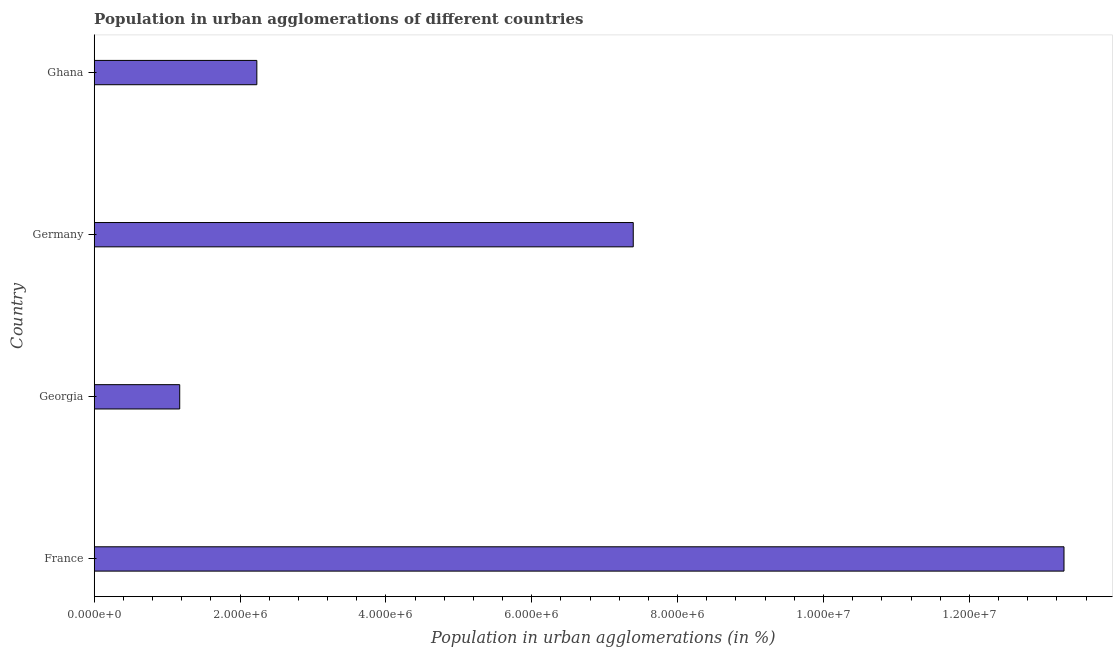Does the graph contain any zero values?
Your answer should be compact. No. What is the title of the graph?
Keep it short and to the point. Population in urban agglomerations of different countries. What is the label or title of the X-axis?
Your answer should be very brief. Population in urban agglomerations (in %). What is the population in urban agglomerations in Germany?
Keep it short and to the point. 7.39e+06. Across all countries, what is the maximum population in urban agglomerations?
Give a very brief answer. 1.33e+07. Across all countries, what is the minimum population in urban agglomerations?
Ensure brevity in your answer.  1.17e+06. In which country was the population in urban agglomerations maximum?
Your response must be concise. France. In which country was the population in urban agglomerations minimum?
Provide a short and direct response. Georgia. What is the sum of the population in urban agglomerations?
Ensure brevity in your answer.  2.41e+07. What is the difference between the population in urban agglomerations in France and Georgia?
Offer a very short reply. 1.21e+07. What is the average population in urban agglomerations per country?
Provide a succinct answer. 6.02e+06. What is the median population in urban agglomerations?
Make the answer very short. 4.81e+06. In how many countries, is the population in urban agglomerations greater than 13200000 %?
Your response must be concise. 1. What is the ratio of the population in urban agglomerations in France to that in Ghana?
Give a very brief answer. 5.96. What is the difference between the highest and the second highest population in urban agglomerations?
Make the answer very short. 5.91e+06. What is the difference between the highest and the lowest population in urban agglomerations?
Provide a short and direct response. 1.21e+07. In how many countries, is the population in urban agglomerations greater than the average population in urban agglomerations taken over all countries?
Your response must be concise. 2. How many bars are there?
Offer a very short reply. 4. How many countries are there in the graph?
Give a very brief answer. 4. Are the values on the major ticks of X-axis written in scientific E-notation?
Provide a short and direct response. Yes. What is the Population in urban agglomerations (in %) of France?
Give a very brief answer. 1.33e+07. What is the Population in urban agglomerations (in %) of Georgia?
Give a very brief answer. 1.17e+06. What is the Population in urban agglomerations (in %) in Germany?
Your answer should be very brief. 7.39e+06. What is the Population in urban agglomerations (in %) in Ghana?
Make the answer very short. 2.23e+06. What is the difference between the Population in urban agglomerations (in %) in France and Georgia?
Keep it short and to the point. 1.21e+07. What is the difference between the Population in urban agglomerations (in %) in France and Germany?
Your answer should be compact. 5.91e+06. What is the difference between the Population in urban agglomerations (in %) in France and Ghana?
Provide a short and direct response. 1.11e+07. What is the difference between the Population in urban agglomerations (in %) in Georgia and Germany?
Provide a short and direct response. -6.22e+06. What is the difference between the Population in urban agglomerations (in %) in Georgia and Ghana?
Offer a terse response. -1.06e+06. What is the difference between the Population in urban agglomerations (in %) in Germany and Ghana?
Offer a very short reply. 5.16e+06. What is the ratio of the Population in urban agglomerations (in %) in France to that in Georgia?
Your answer should be compact. 11.34. What is the ratio of the Population in urban agglomerations (in %) in France to that in Germany?
Your answer should be very brief. 1.8. What is the ratio of the Population in urban agglomerations (in %) in France to that in Ghana?
Make the answer very short. 5.96. What is the ratio of the Population in urban agglomerations (in %) in Georgia to that in Germany?
Offer a very short reply. 0.16. What is the ratio of the Population in urban agglomerations (in %) in Georgia to that in Ghana?
Offer a terse response. 0.53. What is the ratio of the Population in urban agglomerations (in %) in Germany to that in Ghana?
Provide a short and direct response. 3.31. 